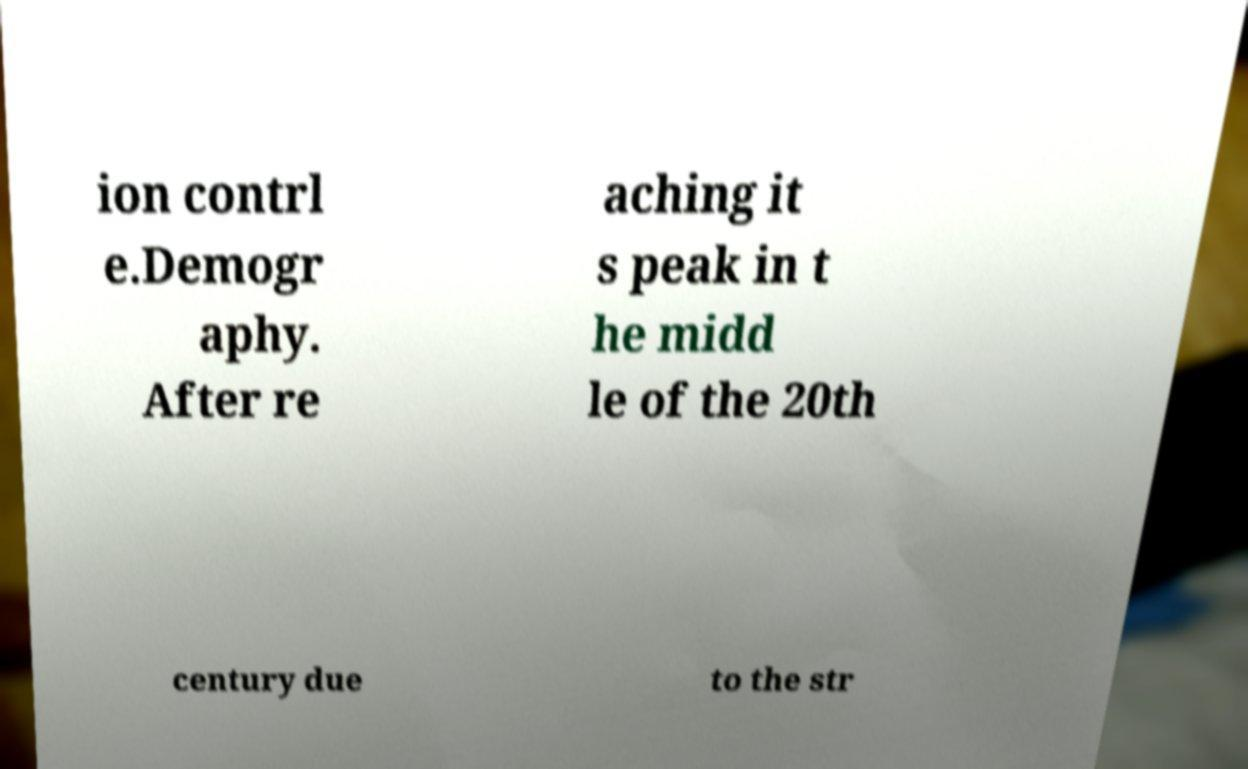What messages or text are displayed in this image? I need them in a readable, typed format. ion contrl e.Demogr aphy. After re aching it s peak in t he midd le of the 20th century due to the str 